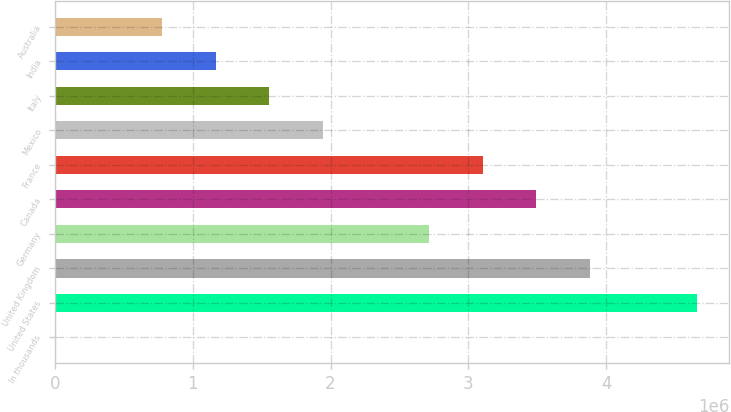<chart> <loc_0><loc_0><loc_500><loc_500><bar_chart><fcel>In thousands<fcel>United States<fcel>United Kingdom<fcel>Germany<fcel>Canada<fcel>France<fcel>Mexico<fcel>Italy<fcel>India<fcel>Australia<nl><fcel>2017<fcel>4.6577e+06<fcel>3.88176e+06<fcel>2.71783e+06<fcel>3.49378e+06<fcel>3.10581e+06<fcel>1.94189e+06<fcel>1.55391e+06<fcel>1.16594e+06<fcel>777965<nl></chart> 